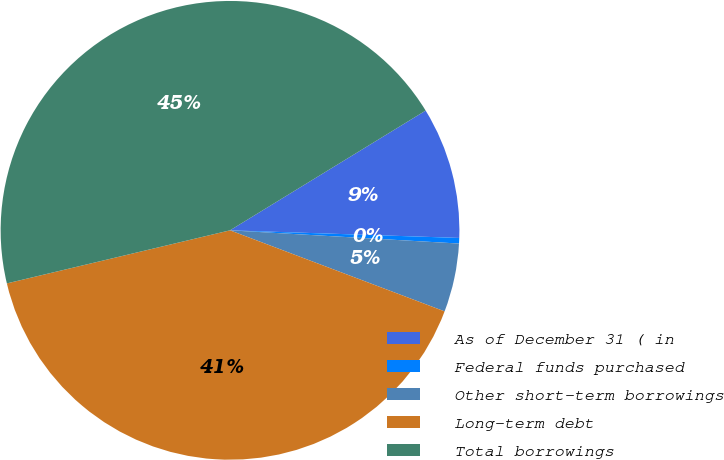Convert chart to OTSL. <chart><loc_0><loc_0><loc_500><loc_500><pie_chart><fcel>As of December 31 ( in<fcel>Federal funds purchased<fcel>Other short-term borrowings<fcel>Long-term debt<fcel>Total borrowings<nl><fcel>9.27%<fcel>0.39%<fcel>4.83%<fcel>40.54%<fcel>44.98%<nl></chart> 